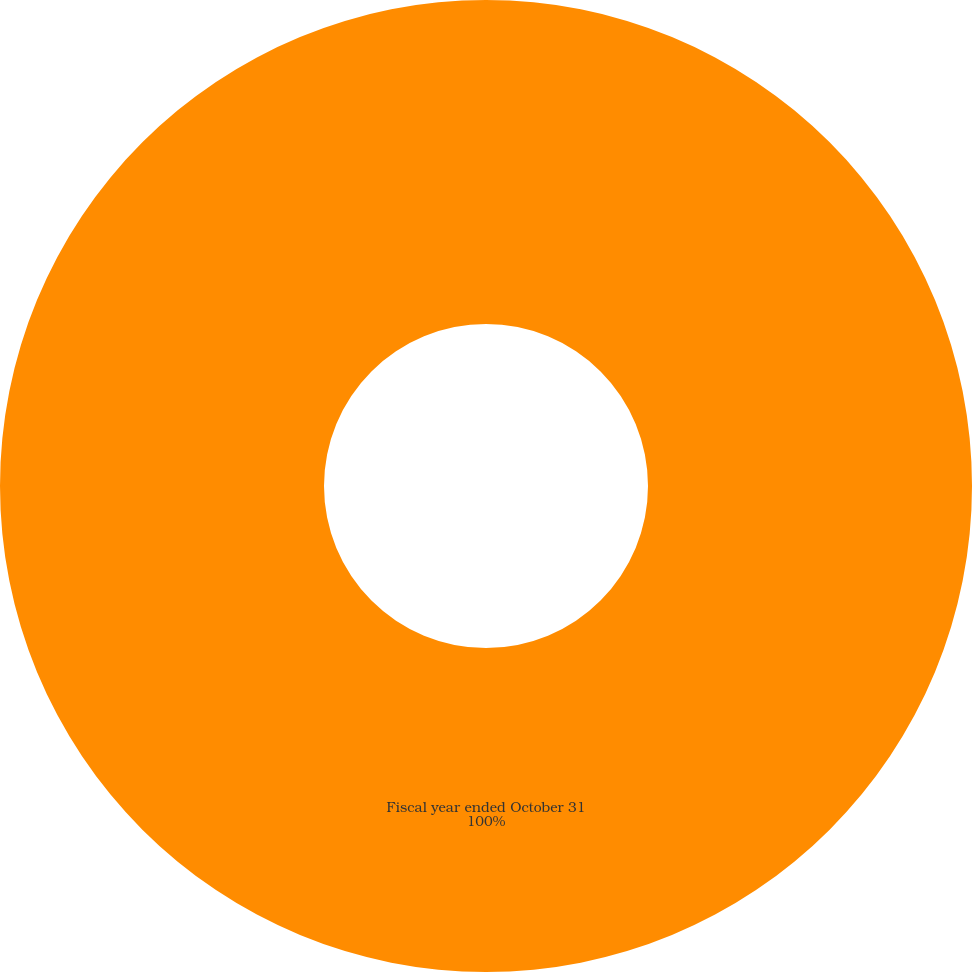<chart> <loc_0><loc_0><loc_500><loc_500><pie_chart><fcel>Fiscal year ended October 31<nl><fcel>100.0%<nl></chart> 